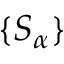<formula> <loc_0><loc_0><loc_500><loc_500>\{ S _ { \alpha } \}</formula> 